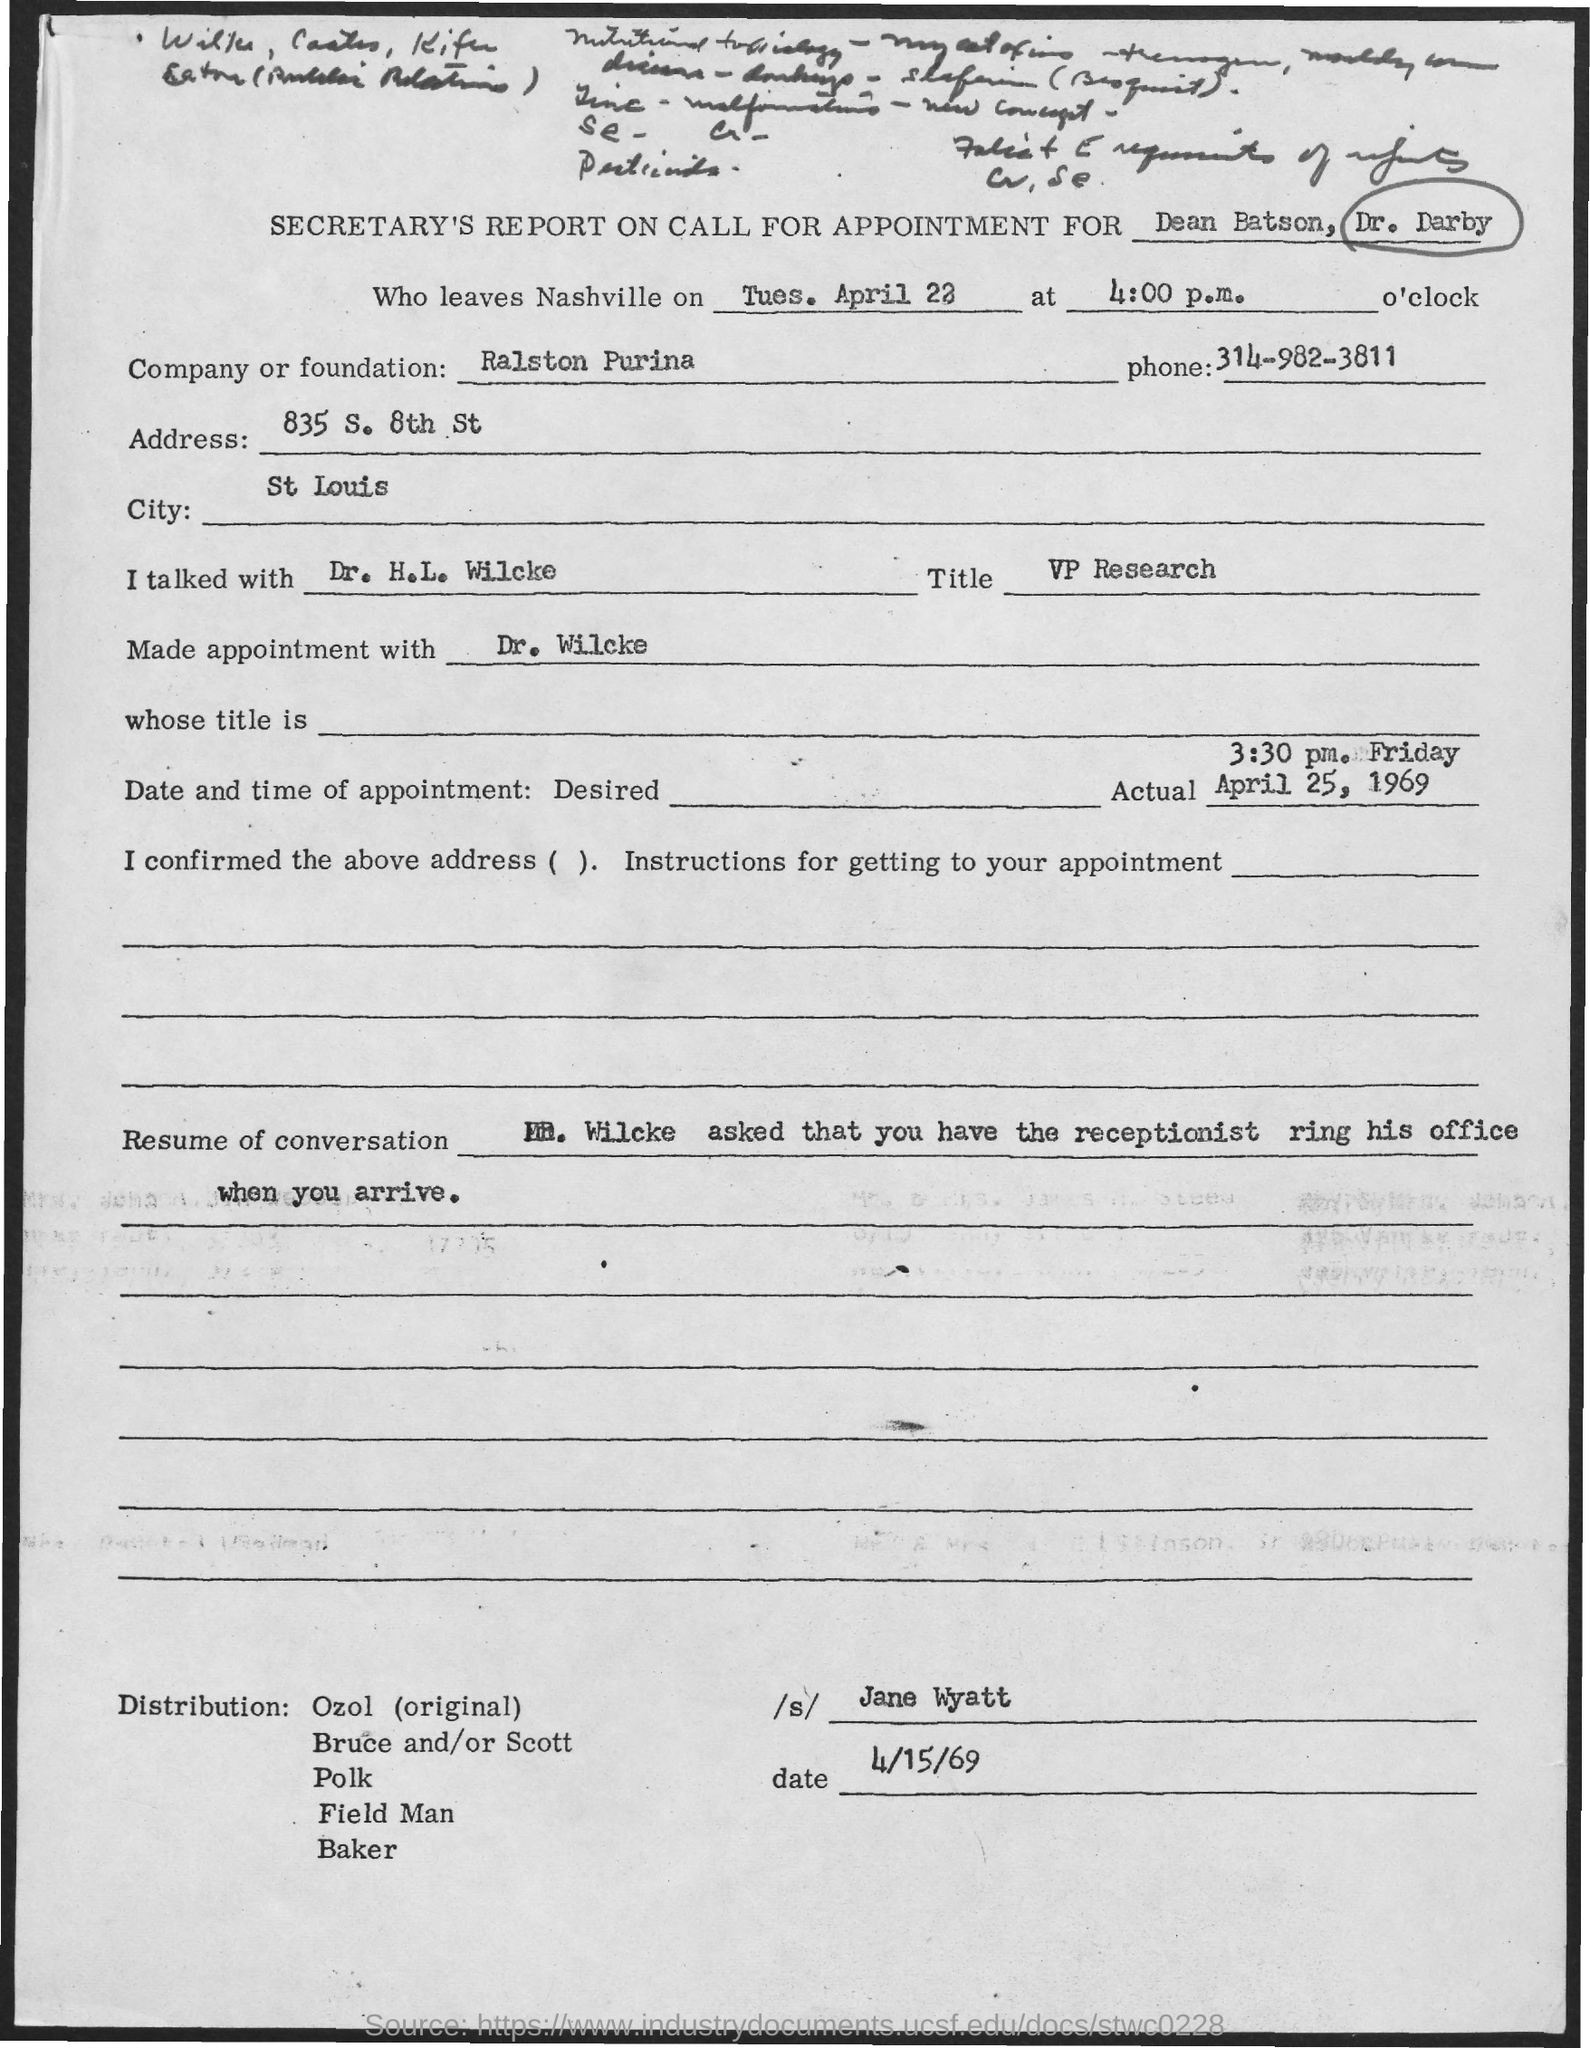What is the company or foundation name mentioned in the document?
Ensure brevity in your answer.  Ralston Purina. What ist he phone no of Ralston Purina?
Your answer should be very brief. 314-982-3811. What is the job title of Dr. H.L. Wilcke?
Keep it short and to the point. VP Research. Who has signed this document?
Provide a succinct answer. Jane Wyatt. 